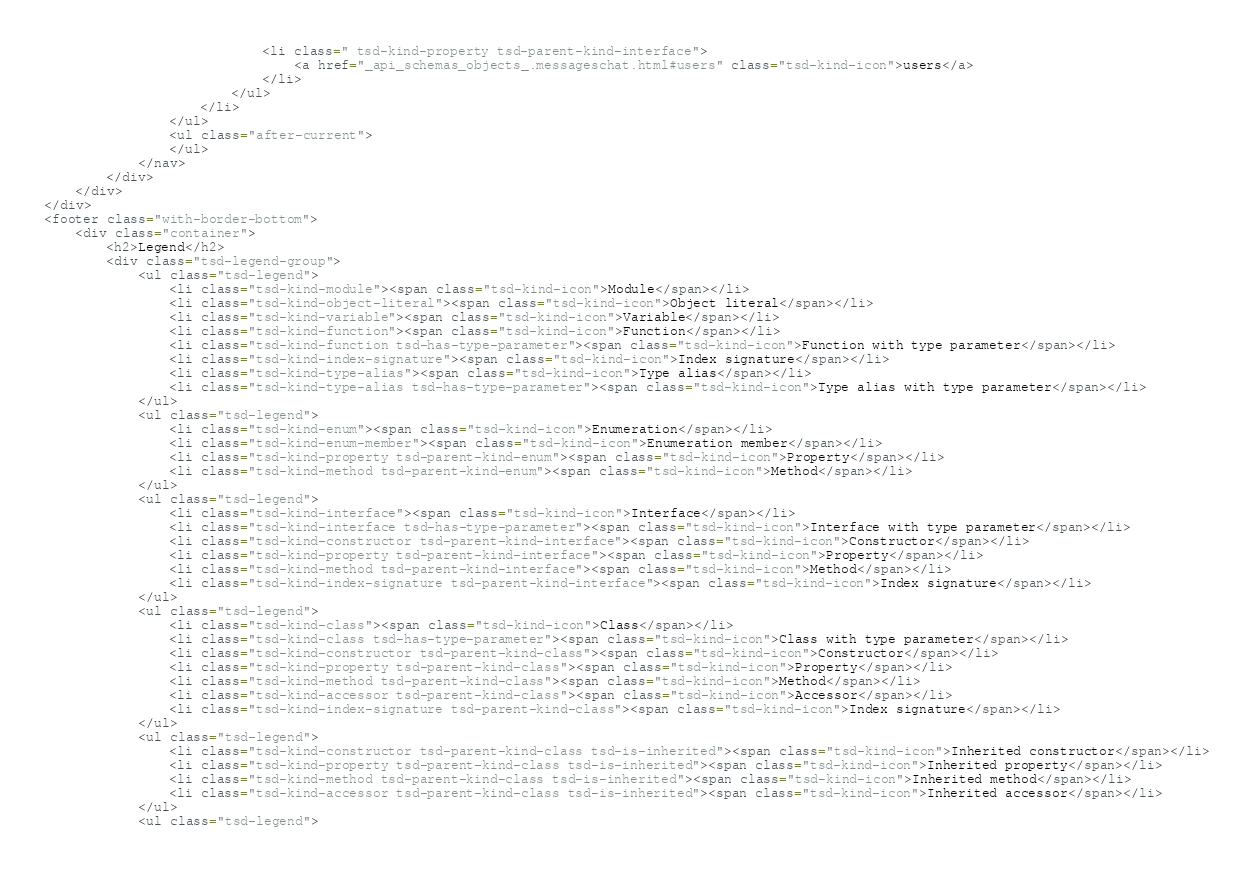Convert code to text. <code><loc_0><loc_0><loc_500><loc_500><_HTML_>							<li class=" tsd-kind-property tsd-parent-kind-interface">
								<a href="_api_schemas_objects_.messageschat.html#users" class="tsd-kind-icon">users</a>
							</li>
						</ul>
					</li>
				</ul>
				<ul class="after-current">
				</ul>
			</nav>
		</div>
	</div>
</div>
<footer class="with-border-bottom">
	<div class="container">
		<h2>Legend</h2>
		<div class="tsd-legend-group">
			<ul class="tsd-legend">
				<li class="tsd-kind-module"><span class="tsd-kind-icon">Module</span></li>
				<li class="tsd-kind-object-literal"><span class="tsd-kind-icon">Object literal</span></li>
				<li class="tsd-kind-variable"><span class="tsd-kind-icon">Variable</span></li>
				<li class="tsd-kind-function"><span class="tsd-kind-icon">Function</span></li>
				<li class="tsd-kind-function tsd-has-type-parameter"><span class="tsd-kind-icon">Function with type parameter</span></li>
				<li class="tsd-kind-index-signature"><span class="tsd-kind-icon">Index signature</span></li>
				<li class="tsd-kind-type-alias"><span class="tsd-kind-icon">Type alias</span></li>
				<li class="tsd-kind-type-alias tsd-has-type-parameter"><span class="tsd-kind-icon">Type alias with type parameter</span></li>
			</ul>
			<ul class="tsd-legend">
				<li class="tsd-kind-enum"><span class="tsd-kind-icon">Enumeration</span></li>
				<li class="tsd-kind-enum-member"><span class="tsd-kind-icon">Enumeration member</span></li>
				<li class="tsd-kind-property tsd-parent-kind-enum"><span class="tsd-kind-icon">Property</span></li>
				<li class="tsd-kind-method tsd-parent-kind-enum"><span class="tsd-kind-icon">Method</span></li>
			</ul>
			<ul class="tsd-legend">
				<li class="tsd-kind-interface"><span class="tsd-kind-icon">Interface</span></li>
				<li class="tsd-kind-interface tsd-has-type-parameter"><span class="tsd-kind-icon">Interface with type parameter</span></li>
				<li class="tsd-kind-constructor tsd-parent-kind-interface"><span class="tsd-kind-icon">Constructor</span></li>
				<li class="tsd-kind-property tsd-parent-kind-interface"><span class="tsd-kind-icon">Property</span></li>
				<li class="tsd-kind-method tsd-parent-kind-interface"><span class="tsd-kind-icon">Method</span></li>
				<li class="tsd-kind-index-signature tsd-parent-kind-interface"><span class="tsd-kind-icon">Index signature</span></li>
			</ul>
			<ul class="tsd-legend">
				<li class="tsd-kind-class"><span class="tsd-kind-icon">Class</span></li>
				<li class="tsd-kind-class tsd-has-type-parameter"><span class="tsd-kind-icon">Class with type parameter</span></li>
				<li class="tsd-kind-constructor tsd-parent-kind-class"><span class="tsd-kind-icon">Constructor</span></li>
				<li class="tsd-kind-property tsd-parent-kind-class"><span class="tsd-kind-icon">Property</span></li>
				<li class="tsd-kind-method tsd-parent-kind-class"><span class="tsd-kind-icon">Method</span></li>
				<li class="tsd-kind-accessor tsd-parent-kind-class"><span class="tsd-kind-icon">Accessor</span></li>
				<li class="tsd-kind-index-signature tsd-parent-kind-class"><span class="tsd-kind-icon">Index signature</span></li>
			</ul>
			<ul class="tsd-legend">
				<li class="tsd-kind-constructor tsd-parent-kind-class tsd-is-inherited"><span class="tsd-kind-icon">Inherited constructor</span></li>
				<li class="tsd-kind-property tsd-parent-kind-class tsd-is-inherited"><span class="tsd-kind-icon">Inherited property</span></li>
				<li class="tsd-kind-method tsd-parent-kind-class tsd-is-inherited"><span class="tsd-kind-icon">Inherited method</span></li>
				<li class="tsd-kind-accessor tsd-parent-kind-class tsd-is-inherited"><span class="tsd-kind-icon">Inherited accessor</span></li>
			</ul>
			<ul class="tsd-legend"></code> 